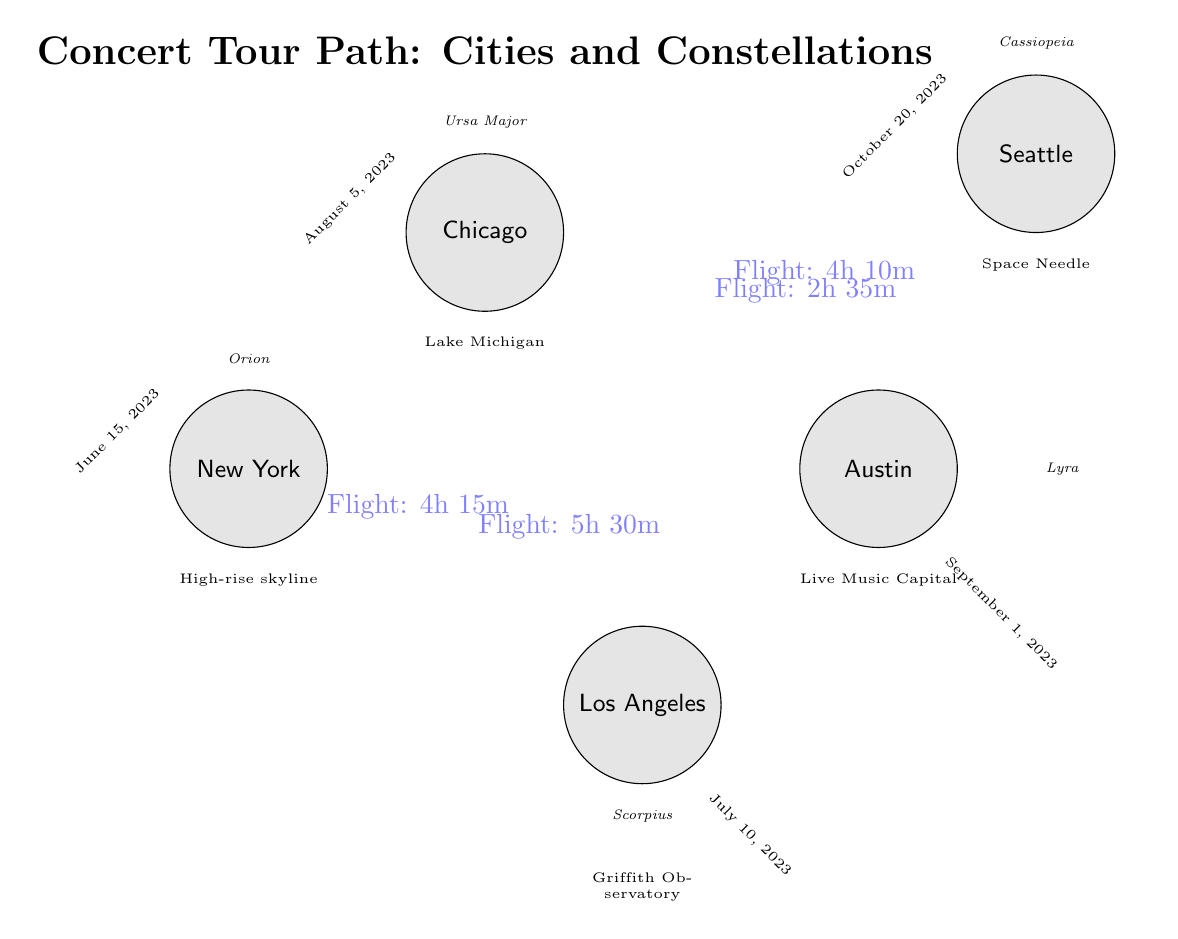What cities are connected by the longest flight path? To determine the longest flight path, we look at the edges connecting the cities. The flights are: New York to Los Angeles (5h 30m), Los Angeles to Chicago (4h 15m), Chicago to Austin (2h 35m), and Austin to Seattle (4h 10m). The longest flight is from New York to Los Angeles, which takes 5 hours and 30 minutes.
Answer: New York and Los Angeles Which constellation is above Chicago? The diagram indicates that the constellation located directly above the city of Chicago is labeled. Upon examining the diagram, the label above Chicago shows "Ursa Major."
Answer: Ursa Major How many total cities are represented in the diagram? By counting the nodes labeled as cities, we find New York, Los Angeles, Chicago, Austin, and Seattle. This results in a total of 5 cities depicted in the diagram.
Answer: 5 What is the date of the concert in Seattle? The concert date can be found under the node representing Seattle. Upon inspection, it shows "October 20, 2023" rotated at an angle near the city label indicating when that concert is scheduled.
Answer: October 20, 2023 Which city features the Griffith Observatory? The city that has the Griffith Observatory is identified by examining the features listed below each city node. In this case, the node for Los Angeles has "Griffith Observatory" directly indicated beneath it.
Answer: Los Angeles 